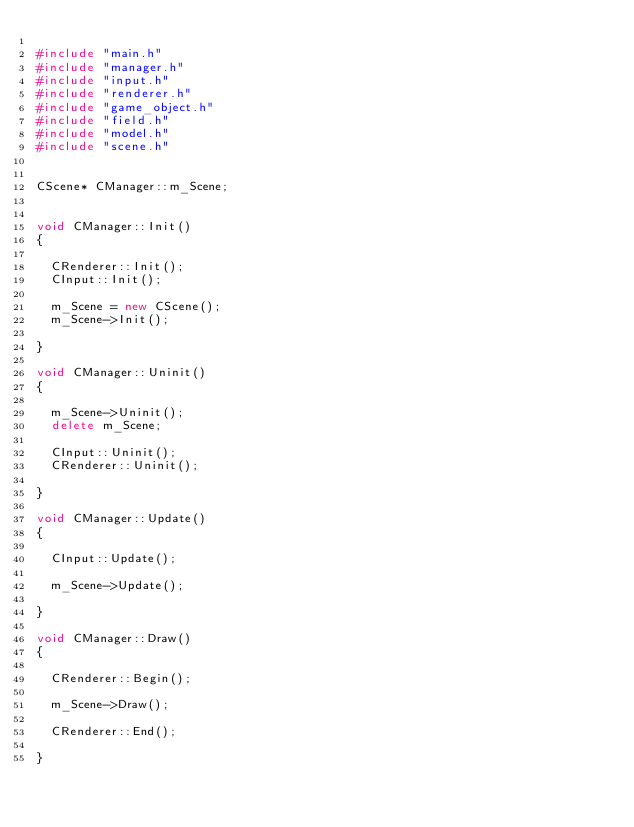Convert code to text. <code><loc_0><loc_0><loc_500><loc_500><_C++_>
#include "main.h"
#include "manager.h"
#include "input.h"
#include "renderer.h"
#include "game_object.h"
#include "field.h"
#include "model.h"
#include "scene.h"


CScene* CManager::m_Scene;


void CManager::Init()
{

	CRenderer::Init();
	CInput::Init();

	m_Scene = new CScene();
	m_Scene->Init();

}

void CManager::Uninit()
{

	m_Scene->Uninit();
	delete m_Scene;

	CInput::Uninit();
	CRenderer::Uninit();

}

void CManager::Update()
{

	CInput::Update();

	m_Scene->Update();

}

void CManager::Draw()
{

	CRenderer::Begin();

	m_Scene->Draw();

	CRenderer::End();

}

</code> 